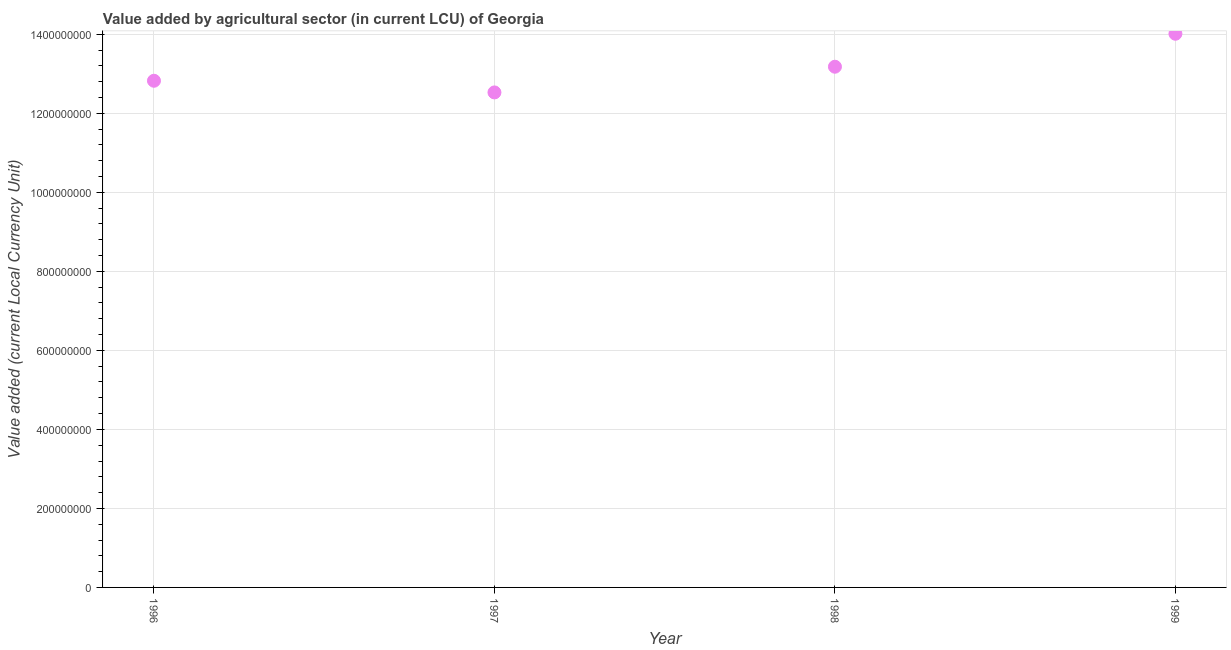What is the value added by agriculture sector in 1997?
Give a very brief answer. 1.25e+09. Across all years, what is the maximum value added by agriculture sector?
Give a very brief answer. 1.40e+09. Across all years, what is the minimum value added by agriculture sector?
Offer a terse response. 1.25e+09. What is the sum of the value added by agriculture sector?
Your response must be concise. 5.25e+09. What is the difference between the value added by agriculture sector in 1996 and 1997?
Your answer should be very brief. 2.95e+07. What is the average value added by agriculture sector per year?
Provide a succinct answer. 1.31e+09. What is the median value added by agriculture sector?
Provide a short and direct response. 1.30e+09. In how many years, is the value added by agriculture sector greater than 800000000 LCU?
Your response must be concise. 4. Do a majority of the years between 1996 and 1997 (inclusive) have value added by agriculture sector greater than 720000000 LCU?
Keep it short and to the point. Yes. What is the ratio of the value added by agriculture sector in 1996 to that in 1997?
Make the answer very short. 1.02. Is the value added by agriculture sector in 1998 less than that in 1999?
Give a very brief answer. Yes. Is the difference between the value added by agriculture sector in 1997 and 1999 greater than the difference between any two years?
Your answer should be compact. Yes. What is the difference between the highest and the second highest value added by agriculture sector?
Your response must be concise. 8.35e+07. What is the difference between the highest and the lowest value added by agriculture sector?
Provide a short and direct response. 1.48e+08. Does the value added by agriculture sector monotonically increase over the years?
Make the answer very short. No. How many dotlines are there?
Your answer should be very brief. 1. How many years are there in the graph?
Provide a succinct answer. 4. What is the difference between two consecutive major ticks on the Y-axis?
Your response must be concise. 2.00e+08. Are the values on the major ticks of Y-axis written in scientific E-notation?
Your response must be concise. No. Does the graph contain any zero values?
Make the answer very short. No. Does the graph contain grids?
Offer a very short reply. Yes. What is the title of the graph?
Your answer should be very brief. Value added by agricultural sector (in current LCU) of Georgia. What is the label or title of the X-axis?
Make the answer very short. Year. What is the label or title of the Y-axis?
Provide a succinct answer. Value added (current Local Currency Unit). What is the Value added (current Local Currency Unit) in 1996?
Make the answer very short. 1.28e+09. What is the Value added (current Local Currency Unit) in 1997?
Make the answer very short. 1.25e+09. What is the Value added (current Local Currency Unit) in 1998?
Ensure brevity in your answer.  1.32e+09. What is the Value added (current Local Currency Unit) in 1999?
Your answer should be very brief. 1.40e+09. What is the difference between the Value added (current Local Currency Unit) in 1996 and 1997?
Your answer should be compact. 2.95e+07. What is the difference between the Value added (current Local Currency Unit) in 1996 and 1998?
Provide a succinct answer. -3.55e+07. What is the difference between the Value added (current Local Currency Unit) in 1996 and 1999?
Your answer should be very brief. -1.19e+08. What is the difference between the Value added (current Local Currency Unit) in 1997 and 1998?
Give a very brief answer. -6.50e+07. What is the difference between the Value added (current Local Currency Unit) in 1997 and 1999?
Offer a terse response. -1.48e+08. What is the difference between the Value added (current Local Currency Unit) in 1998 and 1999?
Your answer should be compact. -8.35e+07. What is the ratio of the Value added (current Local Currency Unit) in 1996 to that in 1997?
Provide a short and direct response. 1.02. What is the ratio of the Value added (current Local Currency Unit) in 1996 to that in 1998?
Keep it short and to the point. 0.97. What is the ratio of the Value added (current Local Currency Unit) in 1996 to that in 1999?
Keep it short and to the point. 0.92. What is the ratio of the Value added (current Local Currency Unit) in 1997 to that in 1998?
Your response must be concise. 0.95. What is the ratio of the Value added (current Local Currency Unit) in 1997 to that in 1999?
Make the answer very short. 0.89. What is the ratio of the Value added (current Local Currency Unit) in 1998 to that in 1999?
Provide a succinct answer. 0.94. 